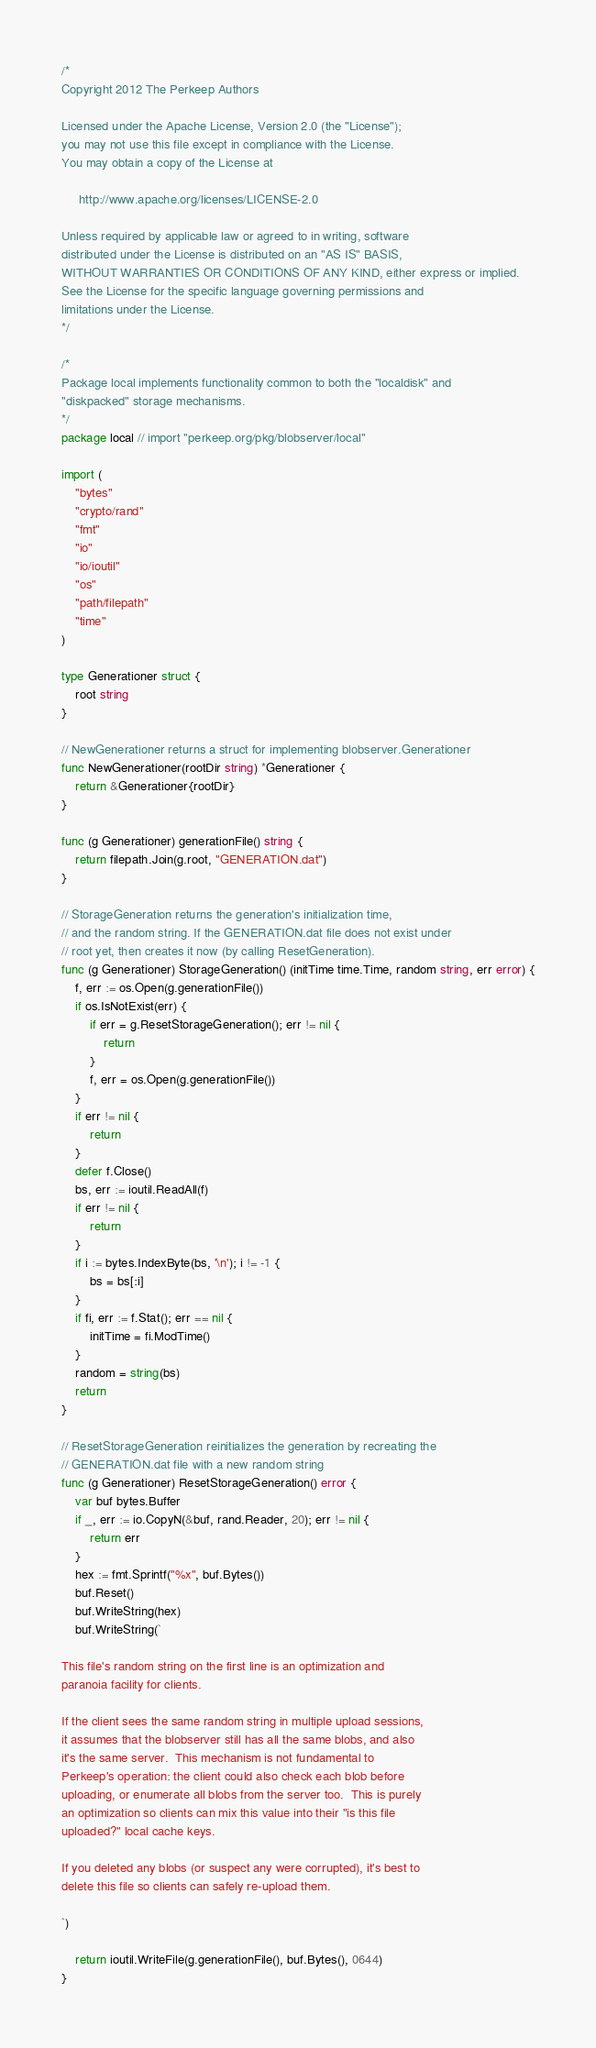Convert code to text. <code><loc_0><loc_0><loc_500><loc_500><_Go_>/*
Copyright 2012 The Perkeep Authors

Licensed under the Apache License, Version 2.0 (the "License");
you may not use this file except in compliance with the License.
You may obtain a copy of the License at

     http://www.apache.org/licenses/LICENSE-2.0

Unless required by applicable law or agreed to in writing, software
distributed under the License is distributed on an "AS IS" BASIS,
WITHOUT WARRANTIES OR CONDITIONS OF ANY KIND, either express or implied.
See the License for the specific language governing permissions and
limitations under the License.
*/

/*
Package local implements functionality common to both the "localdisk" and
"diskpacked" storage mechanisms.
*/
package local // import "perkeep.org/pkg/blobserver/local"

import (
	"bytes"
	"crypto/rand"
	"fmt"
	"io"
	"io/ioutil"
	"os"
	"path/filepath"
	"time"
)

type Generationer struct {
	root string
}

// NewGenerationer returns a struct for implementing blobserver.Generationer
func NewGenerationer(rootDir string) *Generationer {
	return &Generationer{rootDir}
}

func (g Generationer) generationFile() string {
	return filepath.Join(g.root, "GENERATION.dat")
}

// StorageGeneration returns the generation's initialization time,
// and the random string. If the GENERATION.dat file does not exist under
// root yet, then creates it now (by calling ResetGeneration).
func (g Generationer) StorageGeneration() (initTime time.Time, random string, err error) {
	f, err := os.Open(g.generationFile())
	if os.IsNotExist(err) {
		if err = g.ResetStorageGeneration(); err != nil {
			return
		}
		f, err = os.Open(g.generationFile())
	}
	if err != nil {
		return
	}
	defer f.Close()
	bs, err := ioutil.ReadAll(f)
	if err != nil {
		return
	}
	if i := bytes.IndexByte(bs, '\n'); i != -1 {
		bs = bs[:i]
	}
	if fi, err := f.Stat(); err == nil {
		initTime = fi.ModTime()
	}
	random = string(bs)
	return
}

// ResetStorageGeneration reinitializes the generation by recreating the
// GENERATION.dat file with a new random string
func (g Generationer) ResetStorageGeneration() error {
	var buf bytes.Buffer
	if _, err := io.CopyN(&buf, rand.Reader, 20); err != nil {
		return err
	}
	hex := fmt.Sprintf("%x", buf.Bytes())
	buf.Reset()
	buf.WriteString(hex)
	buf.WriteString(`

This file's random string on the first line is an optimization and
paranoia facility for clients.

If the client sees the same random string in multiple upload sessions,
it assumes that the blobserver still has all the same blobs, and also
it's the same server.  This mechanism is not fundamental to
Perkeep's operation: the client could also check each blob before
uploading, or enumerate all blobs from the server too.  This is purely
an optimization so clients can mix this value into their "is this file
uploaded?" local cache keys.

If you deleted any blobs (or suspect any were corrupted), it's best to
delete this file so clients can safely re-upload them.

`)

	return ioutil.WriteFile(g.generationFile(), buf.Bytes(), 0644)
}
</code> 